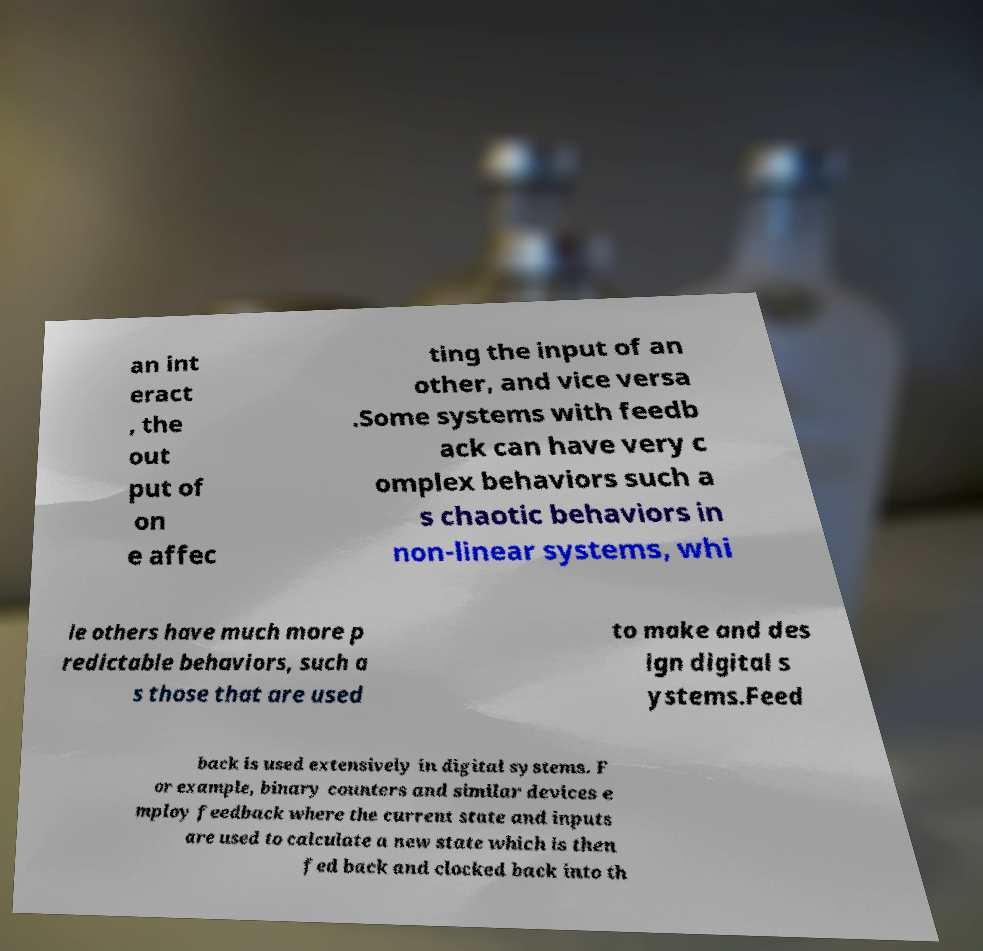Please identify and transcribe the text found in this image. an int eract , the out put of on e affec ting the input of an other, and vice versa .Some systems with feedb ack can have very c omplex behaviors such a s chaotic behaviors in non-linear systems, whi le others have much more p redictable behaviors, such a s those that are used to make and des ign digital s ystems.Feed back is used extensively in digital systems. F or example, binary counters and similar devices e mploy feedback where the current state and inputs are used to calculate a new state which is then fed back and clocked back into th 